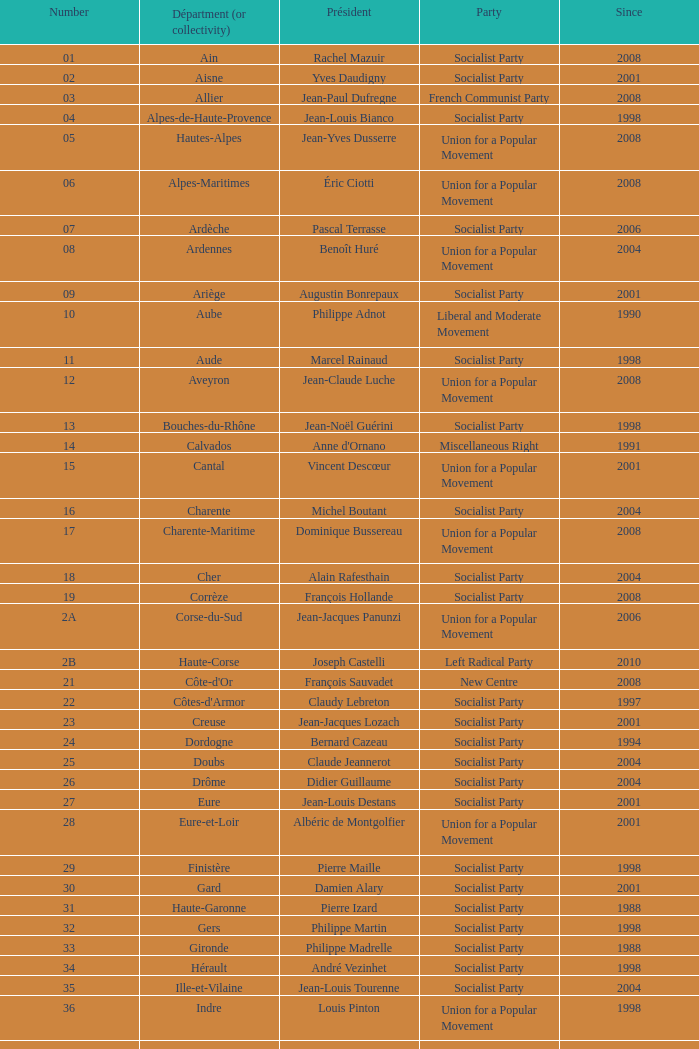Which department has Guy-Dominique Kennel as president since 2008? Bas-Rhin. 